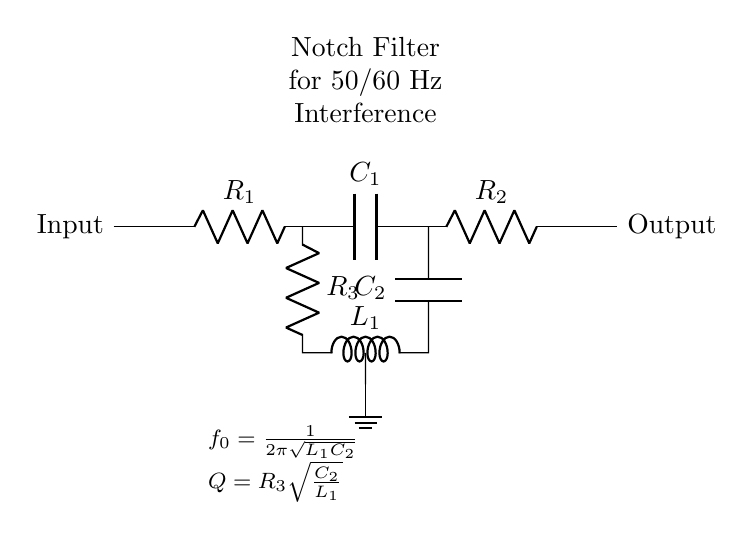What is the purpose of this circuit? The purpose of this circuit is to remove power line interference, typically at frequencies of 50 or 60 Hz, which is common in digital measurement equipment. The notch filter specifically targets this frequency to reduce noise while allowing other frequencies to pass through.
Answer: Remove power line interference What is the component C1? The component labeled as C1 in the circuit diagram is a capacitor. Capacitors in notch filters play a significant role in determining the frequency response of the circuit, including the notch frequency.
Answer: Capacitor What is the formula for the notch frequency f0? The formula given for the notch frequency f0 can be derived from the circuit parameters involving inductance and capacitance. It is stated as f0 = 1/(2π√(L1C2)), where L1 is the inductance and C2 is the capacitance. This formula is crucial for designing the filter to target a specific frequency.
Answer: 1/(2π√(L1C2)) How does changing R3 affect the quality factor Q? The quality factor Q is defined by the relationship Q = R3√(C2/L1). Thus, increasing R3 will lead to a higher Q, which results in a narrower notch, while decreasing R3 will lower Q, resulting in a broader notch. This relationship illustrates the significance of the resistor in fine-tuning the filter's performance.
Answer: Higher Q with increased R3 Is the output of the notch filter in phase with the input? The output of a notch filter is typically not in phase with the input, especially at the notch frequency where significant attenuation occurs. The phase shift depends on the frequency relative to the notch frequency; therefore, at the notch frequency, the output exhibits a phase lag relative to the input.
Answer: Not in phase What happens to signals at frequencies other than 50/60 Hz? Signals at frequencies other than 50 or 60 Hz are allowed to pass through the notch filter with minimal attenuation, meaning that it selectively targets and reduces noise while not affecting the entire signal spectrum. This design is crucial for accurate digital measurements.
Answer: Allowed to pass 